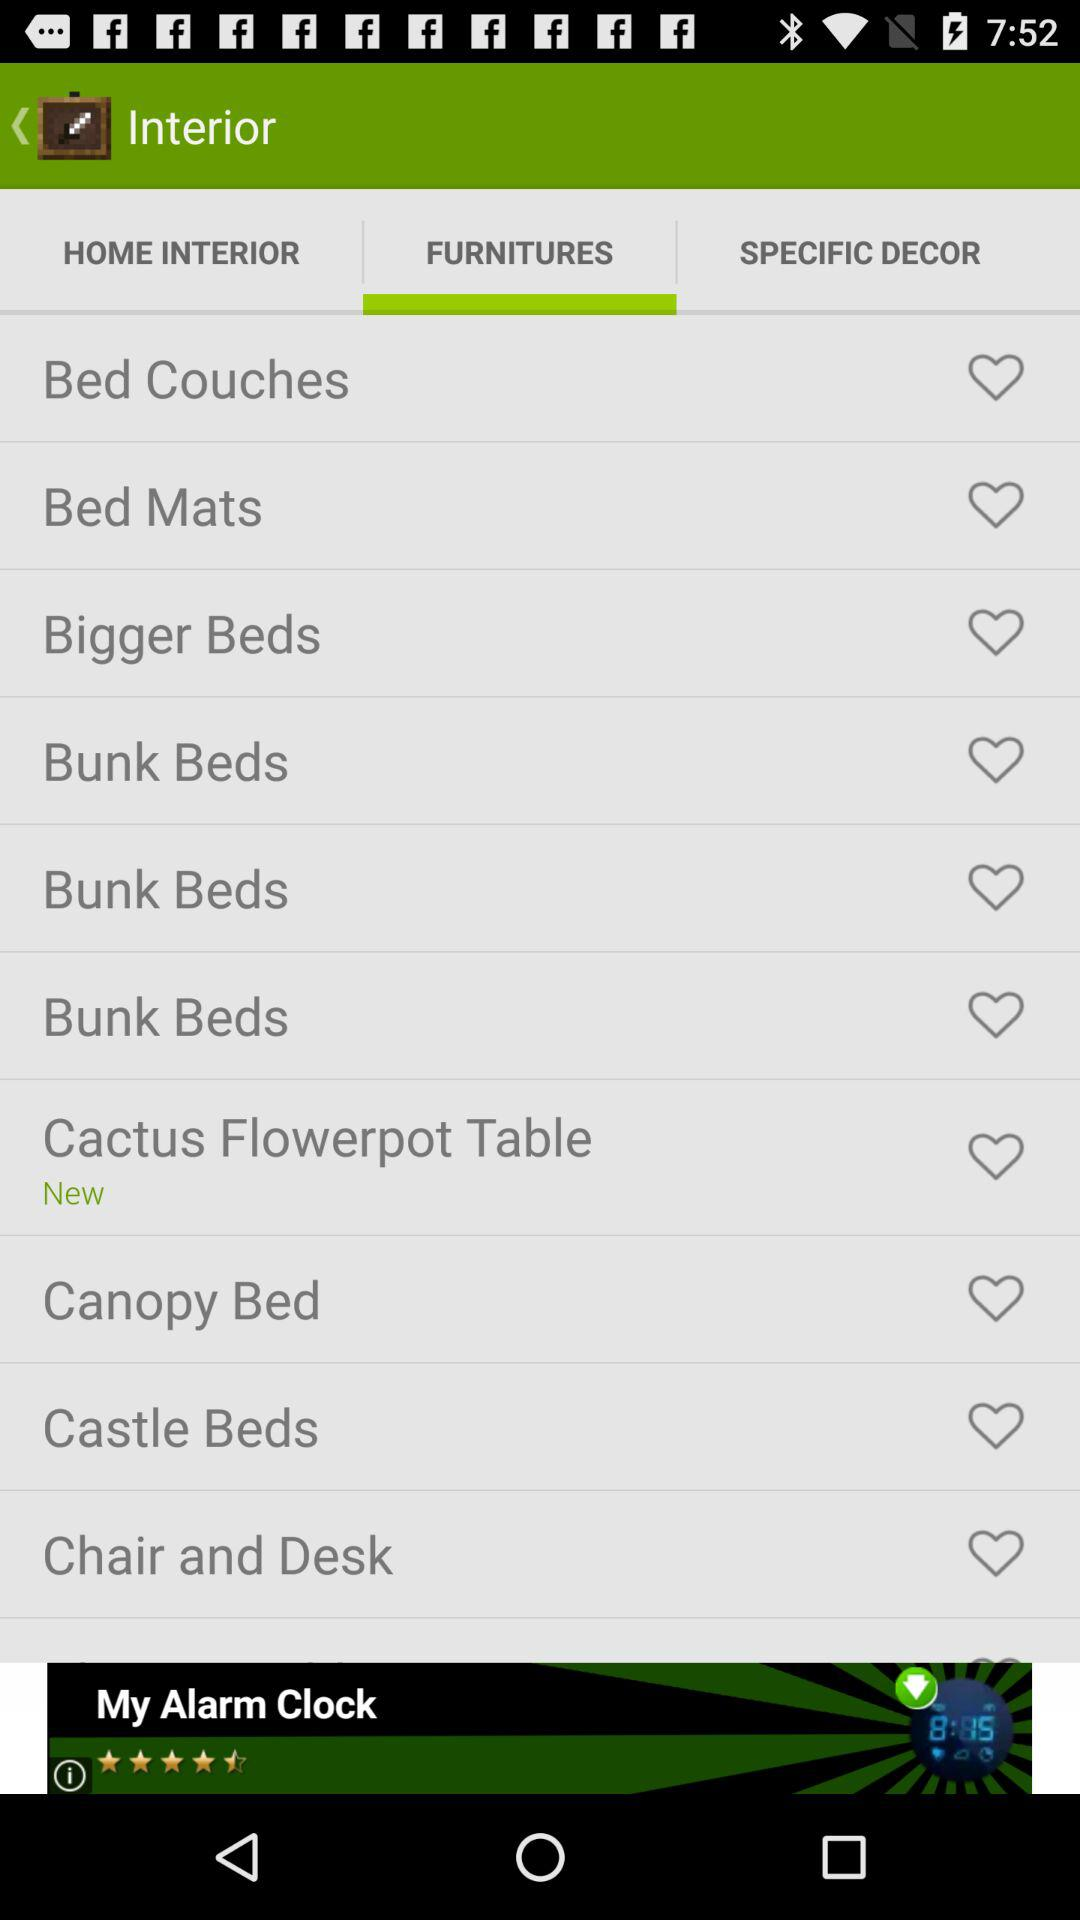Which is the new furniture? The new furniture is the "Cactus Flowerpot Table". 